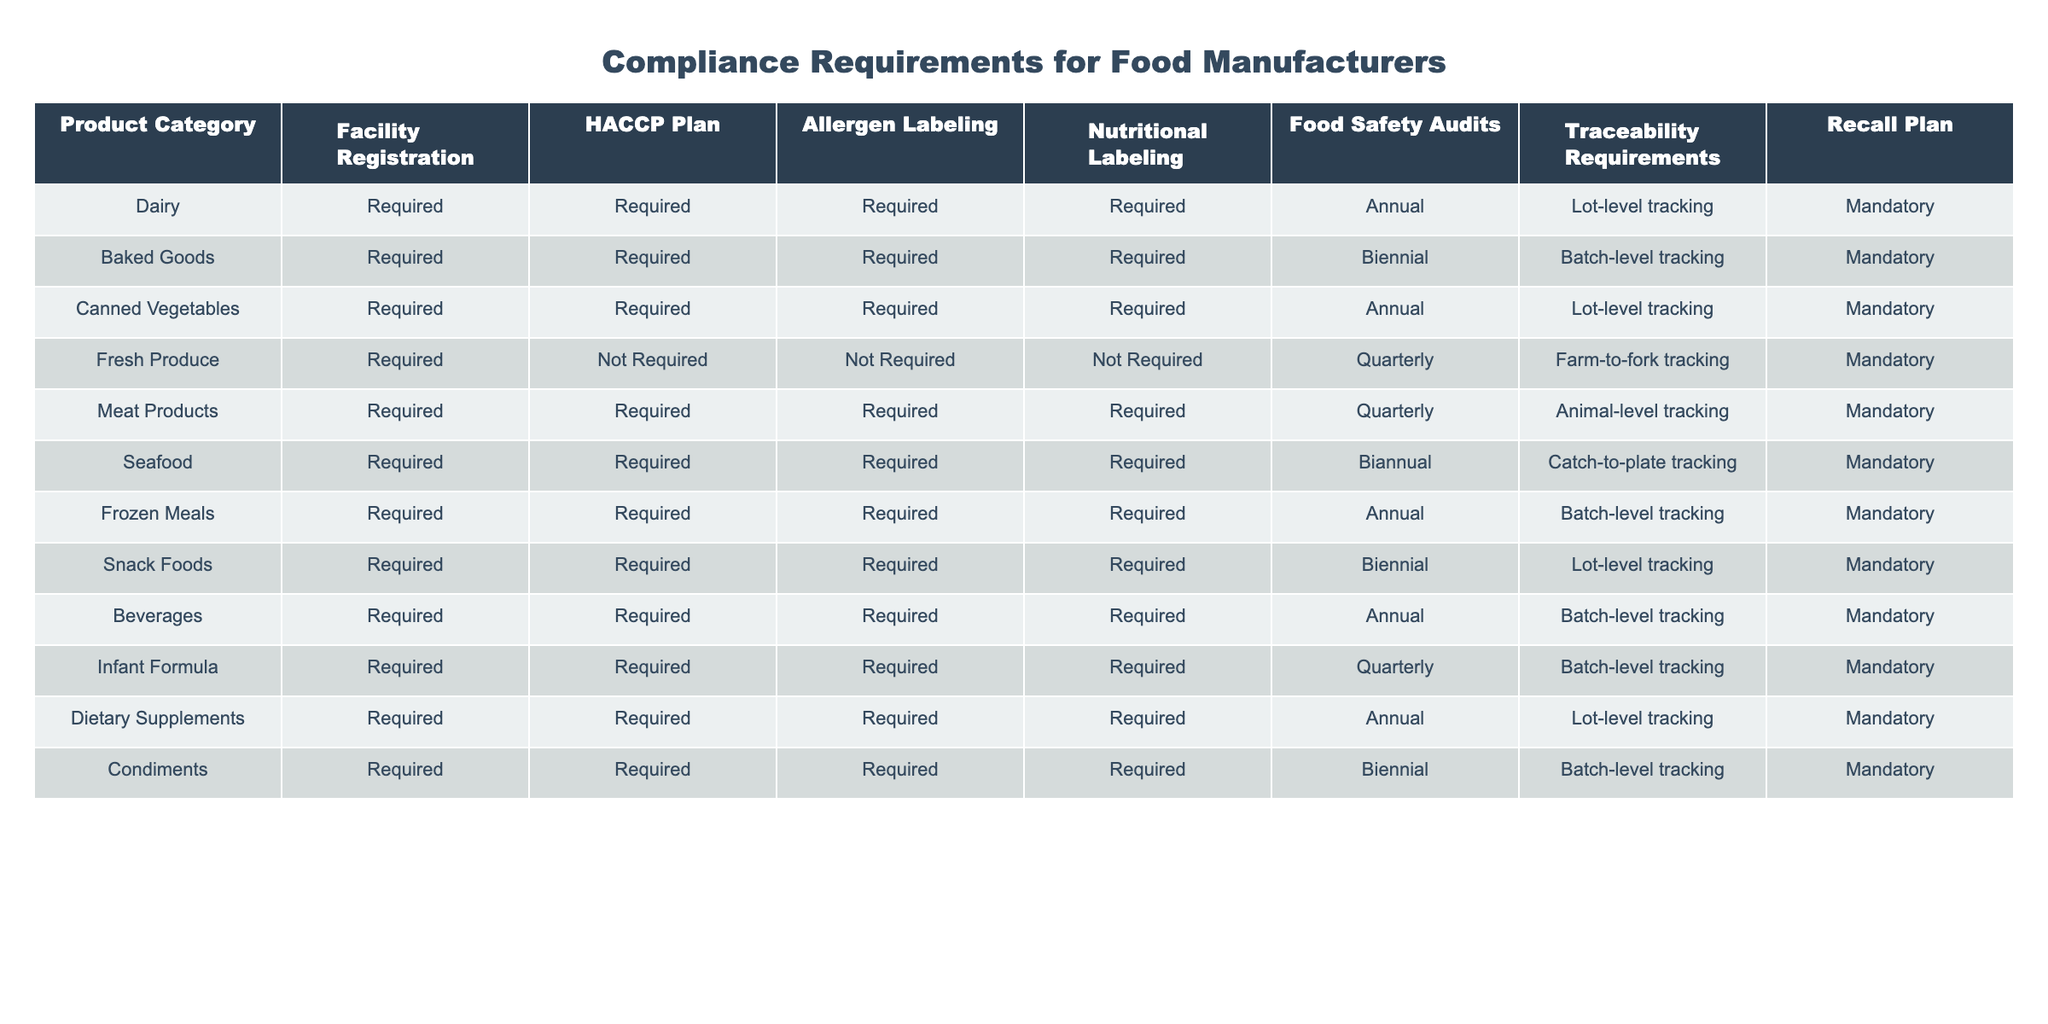What are the compliance requirements for Dairy products? The table states that Dairy products require Facility Registration, HACCP Plan, Allergen Labeling, Nutritional Labeling, Food Safety Audits annually, Lot-level tracking for traceability, and a mandatory Recall Plan.
Answer: Required, Required, Required, Required, Annual, Lot-level tracking, Mandatory How often do Meat Products require Food Safety Audits? According to the table, Meat Products require Food Safety Audits quarterly. This is stated specifically in the Food Safety Audits column under the Meat Products row.
Answer: Quarterly Do Fresh Produce require an HACCP Plan? The table indicates that Fresh Produce do not require an HACCP Plan, as marked in the HACCP Plan column under Fresh Produce.
Answer: No What is the difference in Food Safety Audit frequency between Canned Vegetables and Frozen Meals? The table shows that both Canned Vegetables and Frozen Meals require annual Food Safety Audits. There is no difference in frequency as both are the same.
Answer: No difference How many product categories require Allergen Labeling? By examining the table, we can see that all product categories listed (Dairy, Baked Goods, Canned Vegetables, Meat Products, Seafood, Frozen Meals, Snack Foods, Beverages, Infant Formula, Dietary Supplements, and Condiments) require Allergen Labeling, totaling 11 categories.
Answer: 11 Are Traceability Requirements for Infant Formula more stringent than for Fresh Produce? The table indicates that Traceability Requirements for Infant Formula focus on Batch-level tracking, while Fresh Produce has Farm-to-fork tracking. Since Farm-to-fork tracking is generally more comprehensive than Batch-level tracking, we conclude that they are different in stringency. Therefore, we say that the requirements for Fresh Produce are more stringent.
Answer: Yes What is the average frequency of Food Safety Audits across all product categories? The frequencies from the table are Annual (4), Biennial (3), Quarterly (3). To find the average: (4 + 3 + 3) = 10 categories. Converting frequencies to a numerical scale: Annual = 1, Biennial = 2, Quarterly = 4 gives (1*4 + 2*3 + 4*3) / 10 = (4 + 6 + 12) / 10 = 22 / 10 = 2.2 which is closest to Quarterly.
Answer: Quarterly Which product category has the most frequent Food Safety Audits and how often? By looking through the table, the product categories with the highest frequency of Food Safety Audits are Fresh Produce and Meat Products, both requiring quarterly audits. This indicates that these categories are subject to more frequent checks compared to others.
Answer: Fresh Produce and Meat Products, Quarterly Are there any product categories that do not require Traceability Requirements? The table shows that all product categories listed require some form of Traceability Requirements. Therefore, there are no categories without these requirements.
Answer: No 